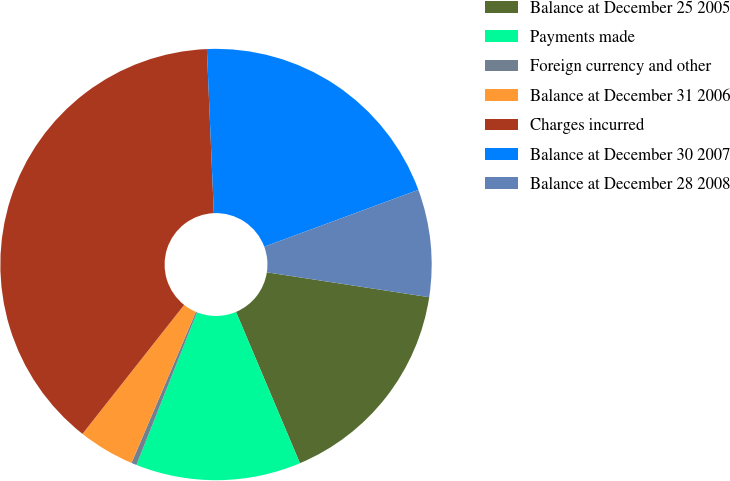Convert chart to OTSL. <chart><loc_0><loc_0><loc_500><loc_500><pie_chart><fcel>Balance at December 25 2005<fcel>Payments made<fcel>Foreign currency and other<fcel>Balance at December 31 2006<fcel>Charges incurred<fcel>Balance at December 30 2007<fcel>Balance at December 28 2008<nl><fcel>16.22%<fcel>12.38%<fcel>0.39%<fcel>4.22%<fcel>38.7%<fcel>20.05%<fcel>8.05%<nl></chart> 